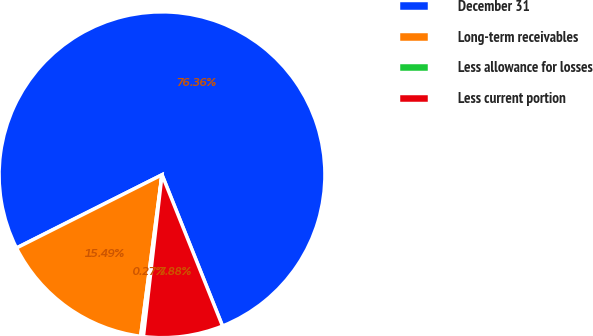Convert chart. <chart><loc_0><loc_0><loc_500><loc_500><pie_chart><fcel>December 31<fcel>Long-term receivables<fcel>Less allowance for losses<fcel>Less current portion<nl><fcel>76.37%<fcel>15.49%<fcel>0.27%<fcel>7.88%<nl></chart> 